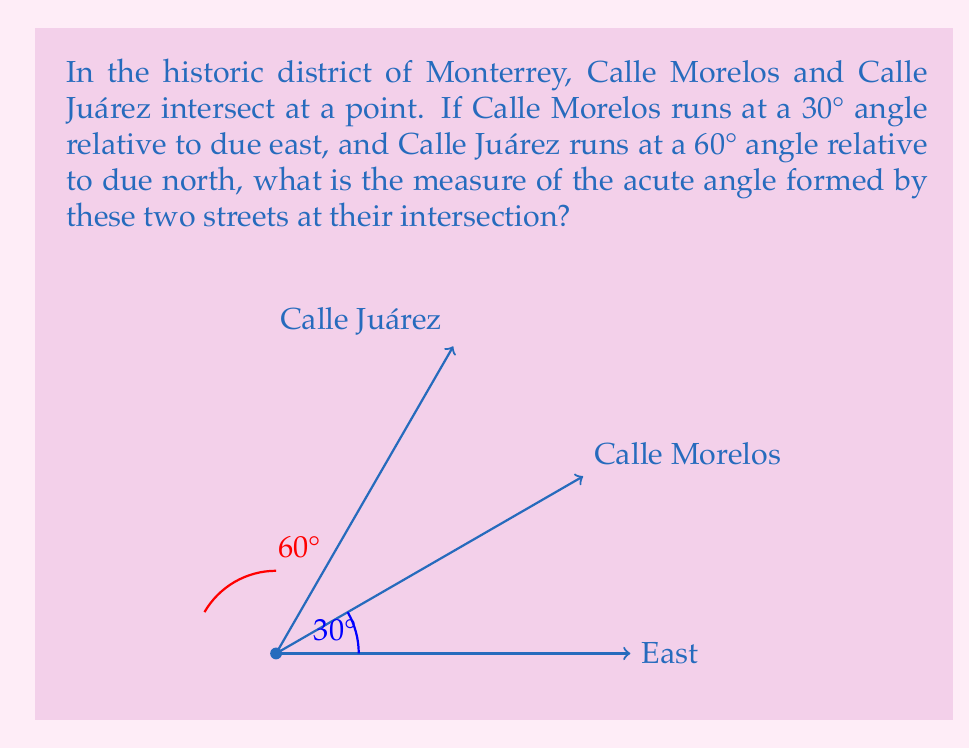Help me with this question. Let's approach this step-by-step:

1) First, we need to understand the given information:
   - Calle Morelos is at a 30° angle from due east
   - Calle Juárez is at a 60° angle from due north

2) To find the angle between these streets, we need to consider their angles relative to the same reference line. Let's use due east as our reference.

3) Calle Morelos is already given relative to east: 30°

4) For Calle Juárez, we need to convert its angle:
   - It's 60° from north
   - North is 90° from east
   - So, Calle Juárez is: $90° - 60° = 30°$ from east

5) Now we have both streets' angles relative to east:
   - Calle Morelos: 30°
   - Calle Juárez: 30°

6) The angle between the streets is the absolute difference between these angles:
   $|30° - 30°| = 0°$

7) However, this gives us the smaller angle. The question asks for the acute angle, which is the smaller of the two angles formed at the intersection.

8) In a full 360° rotation, two lines always form two supplementary angles. The sum of these angles is 180°.

9) So, if one angle is 0°, the other must be:
   $180° - 0° = 180°$

10) The acute angle is the smaller of these two, which is 0°.
Answer: $0°$ 